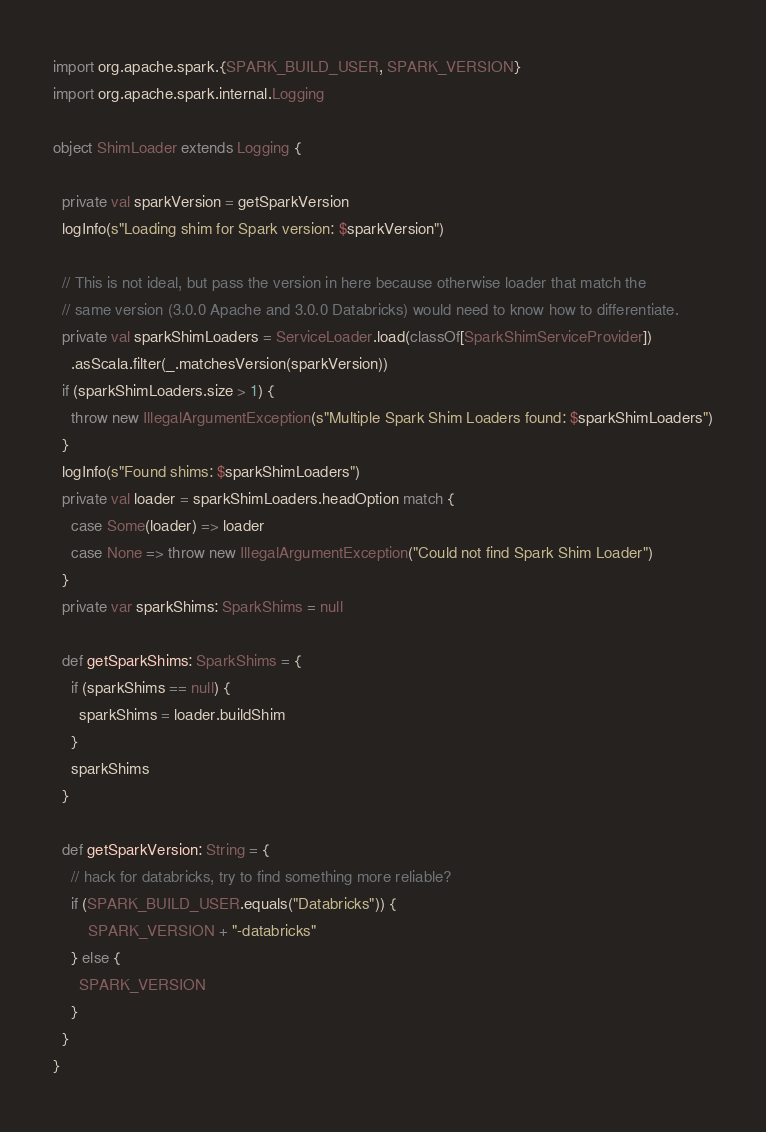<code> <loc_0><loc_0><loc_500><loc_500><_Scala_>
import org.apache.spark.{SPARK_BUILD_USER, SPARK_VERSION}
import org.apache.spark.internal.Logging

object ShimLoader extends Logging {

  private val sparkVersion = getSparkVersion
  logInfo(s"Loading shim for Spark version: $sparkVersion")

  // This is not ideal, but pass the version in here because otherwise loader that match the
  // same version (3.0.0 Apache and 3.0.0 Databricks) would need to know how to differentiate.
  private val sparkShimLoaders = ServiceLoader.load(classOf[SparkShimServiceProvider])
    .asScala.filter(_.matchesVersion(sparkVersion))
  if (sparkShimLoaders.size > 1) {
    throw new IllegalArgumentException(s"Multiple Spark Shim Loaders found: $sparkShimLoaders")
  }
  logInfo(s"Found shims: $sparkShimLoaders")
  private val loader = sparkShimLoaders.headOption match {
    case Some(loader) => loader
    case None => throw new IllegalArgumentException("Could not find Spark Shim Loader")
  }
  private var sparkShims: SparkShims = null

  def getSparkShims: SparkShims = {
    if (sparkShims == null) {
      sparkShims = loader.buildShim
    }
    sparkShims
  }

  def getSparkVersion: String = {
    // hack for databricks, try to find something more reliable?
    if (SPARK_BUILD_USER.equals("Databricks")) {
        SPARK_VERSION + "-databricks"
    } else {
      SPARK_VERSION
    }
  }
}
</code> 